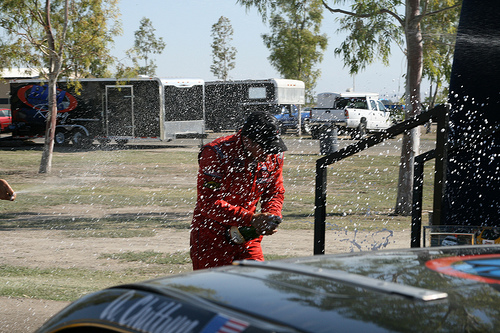<image>
Is there a champagne above the ground? Yes. The champagne is positioned above the ground in the vertical space, higher up in the scene. 